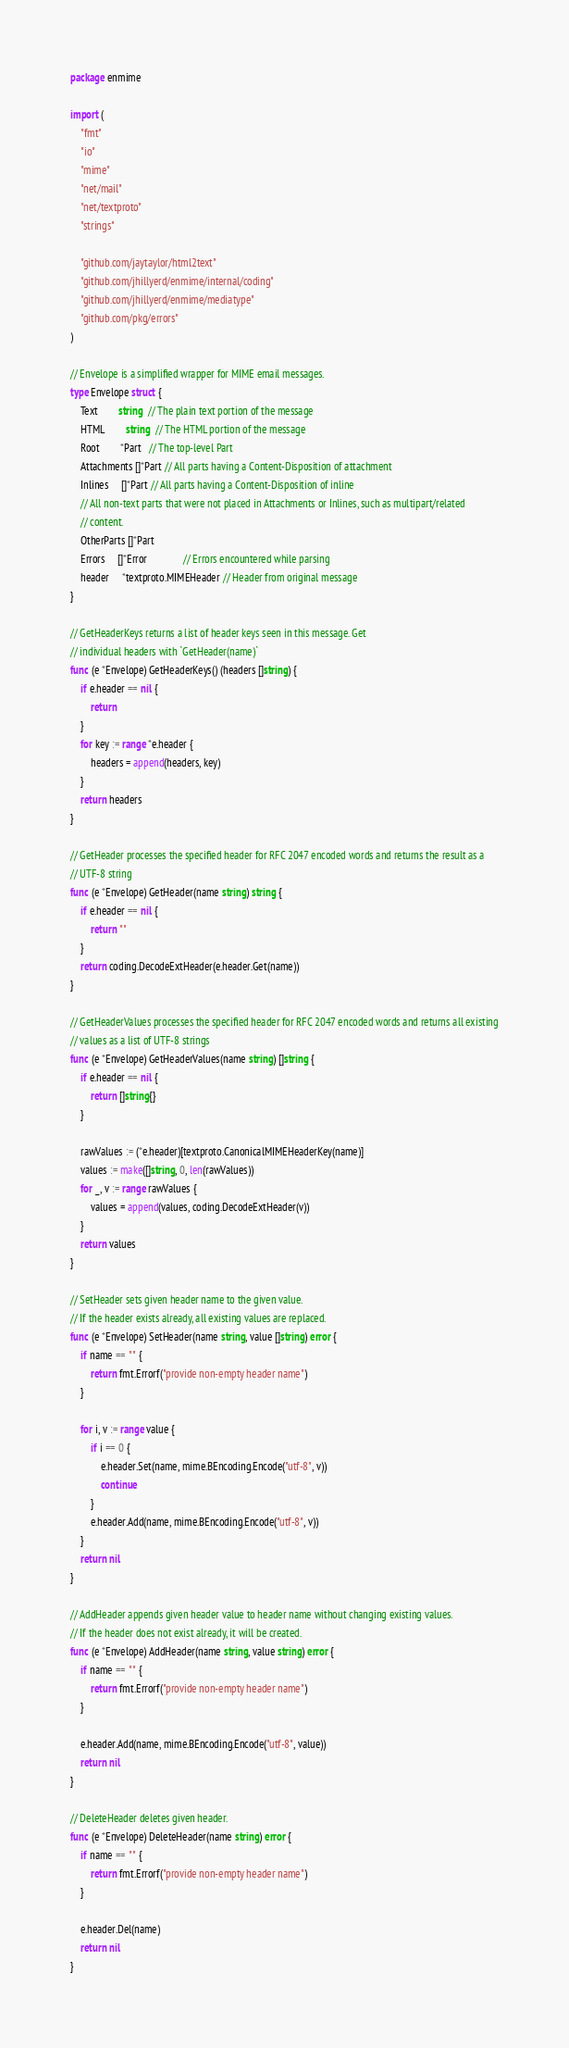<code> <loc_0><loc_0><loc_500><loc_500><_Go_>package enmime

import (
	"fmt"
	"io"
	"mime"
	"net/mail"
	"net/textproto"
	"strings"

	"github.com/jaytaylor/html2text"
	"github.com/jhillyerd/enmime/internal/coding"
	"github.com/jhillyerd/enmime/mediatype"
	"github.com/pkg/errors"
)

// Envelope is a simplified wrapper for MIME email messages.
type Envelope struct {
	Text        string  // The plain text portion of the message
	HTML        string  // The HTML portion of the message
	Root        *Part   // The top-level Part
	Attachments []*Part // All parts having a Content-Disposition of attachment
	Inlines     []*Part // All parts having a Content-Disposition of inline
	// All non-text parts that were not placed in Attachments or Inlines, such as multipart/related
	// content.
	OtherParts []*Part
	Errors     []*Error              // Errors encountered while parsing
	header     *textproto.MIMEHeader // Header from original message
}

// GetHeaderKeys returns a list of header keys seen in this message. Get
// individual headers with `GetHeader(name)`
func (e *Envelope) GetHeaderKeys() (headers []string) {
	if e.header == nil {
		return
	}
	for key := range *e.header {
		headers = append(headers, key)
	}
	return headers
}

// GetHeader processes the specified header for RFC 2047 encoded words and returns the result as a
// UTF-8 string
func (e *Envelope) GetHeader(name string) string {
	if e.header == nil {
		return ""
	}
	return coding.DecodeExtHeader(e.header.Get(name))
}

// GetHeaderValues processes the specified header for RFC 2047 encoded words and returns all existing
// values as a list of UTF-8 strings
func (e *Envelope) GetHeaderValues(name string) []string {
	if e.header == nil {
		return []string{}
	}

	rawValues := (*e.header)[textproto.CanonicalMIMEHeaderKey(name)]
	values := make([]string, 0, len(rawValues))
	for _, v := range rawValues {
		values = append(values, coding.DecodeExtHeader(v))
	}
	return values
}

// SetHeader sets given header name to the given value.
// If the header exists already, all existing values are replaced.
func (e *Envelope) SetHeader(name string, value []string) error {
	if name == "" {
		return fmt.Errorf("provide non-empty header name")
	}

	for i, v := range value {
		if i == 0 {
			e.header.Set(name, mime.BEncoding.Encode("utf-8", v))
			continue
		}
		e.header.Add(name, mime.BEncoding.Encode("utf-8", v))
	}
	return nil
}

// AddHeader appends given header value to header name without changing existing values.
// If the header does not exist already, it will be created.
func (e *Envelope) AddHeader(name string, value string) error {
	if name == "" {
		return fmt.Errorf("provide non-empty header name")
	}

	e.header.Add(name, mime.BEncoding.Encode("utf-8", value))
	return nil
}

// DeleteHeader deletes given header.
func (e *Envelope) DeleteHeader(name string) error {
	if name == "" {
		return fmt.Errorf("provide non-empty header name")
	}

	e.header.Del(name)
	return nil
}
</code> 